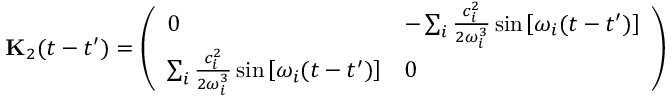<formula> <loc_0><loc_0><loc_500><loc_500>{ K } _ { 2 } ( t - t ^ { \prime } ) = \left ( \begin{array} { l l } { 0 } & { - \sum _ { i } \frac { c _ { i } ^ { 2 } } { 2 \omega _ { i } ^ { 3 } } \sin \left [ \omega _ { i } ( t - t ^ { \prime } ) \right ] } \\ { \sum _ { i } \frac { c _ { i } ^ { 2 } } { 2 \omega _ { i } ^ { 3 } } \sin \left [ \omega _ { i } ( t - t ^ { \prime } ) \right ] } & { 0 } \end{array} \right )</formula> 